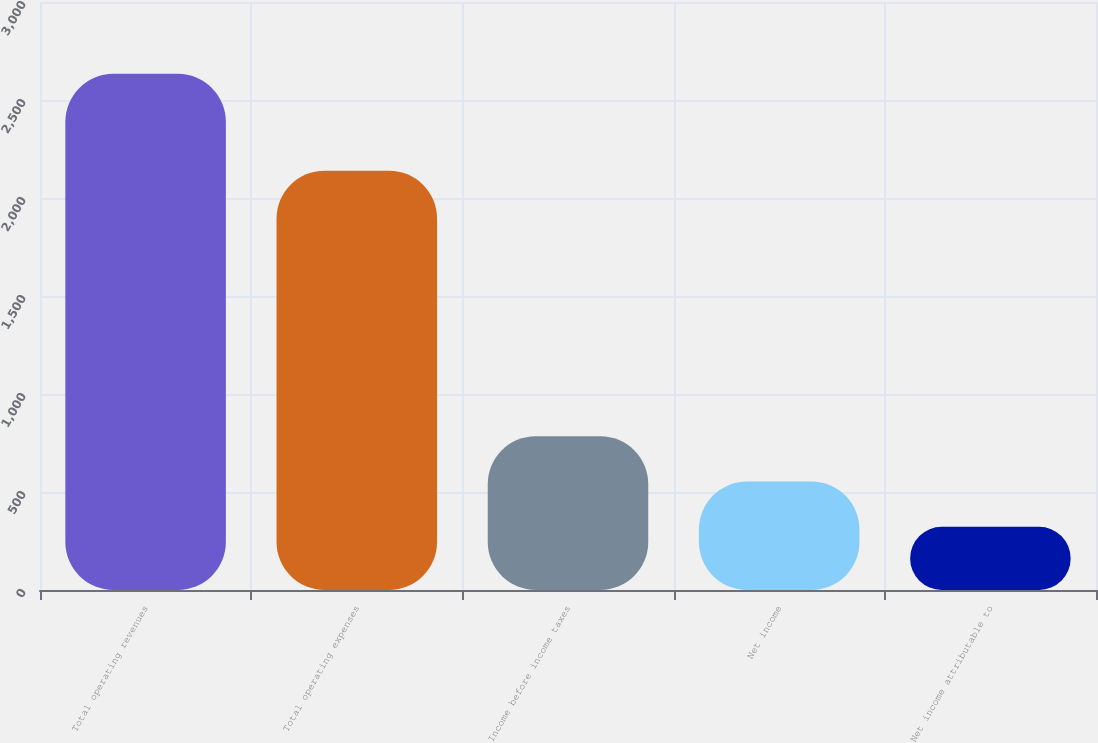Convert chart to OTSL. <chart><loc_0><loc_0><loc_500><loc_500><bar_chart><fcel>Total operating revenues<fcel>Total operating expenses<fcel>Income before income taxes<fcel>Net income<fcel>Net income attributable to<nl><fcel>2633.3<fcel>2139.5<fcel>784.66<fcel>553.58<fcel>322.5<nl></chart> 